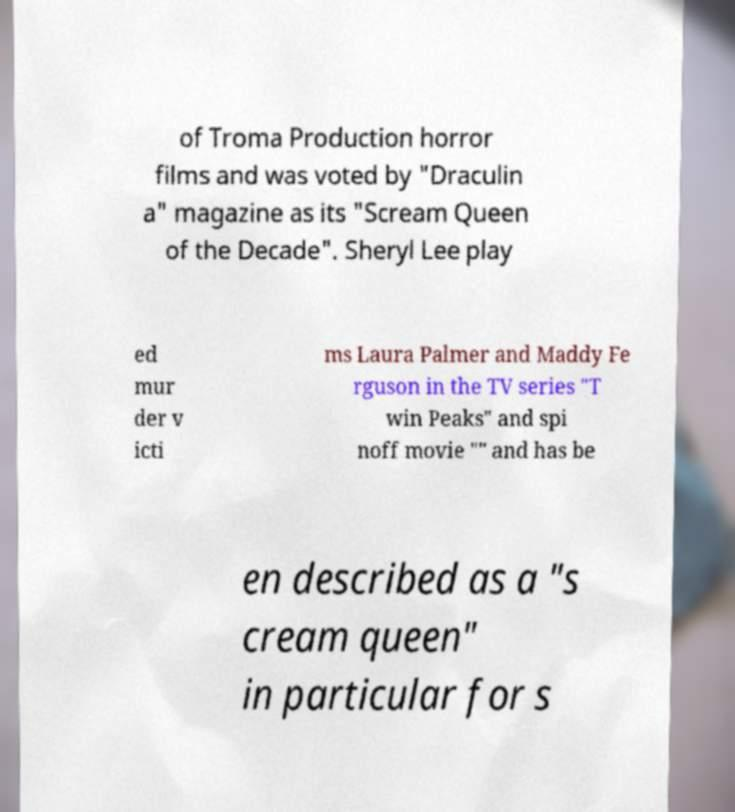Could you extract and type out the text from this image? of Troma Production horror films and was voted by "Draculin a" magazine as its "Scream Queen of the Decade". Sheryl Lee play ed mur der v icti ms Laura Palmer and Maddy Fe rguson in the TV series "T win Peaks" and spi noff movie "" and has be en described as a "s cream queen" in particular for s 